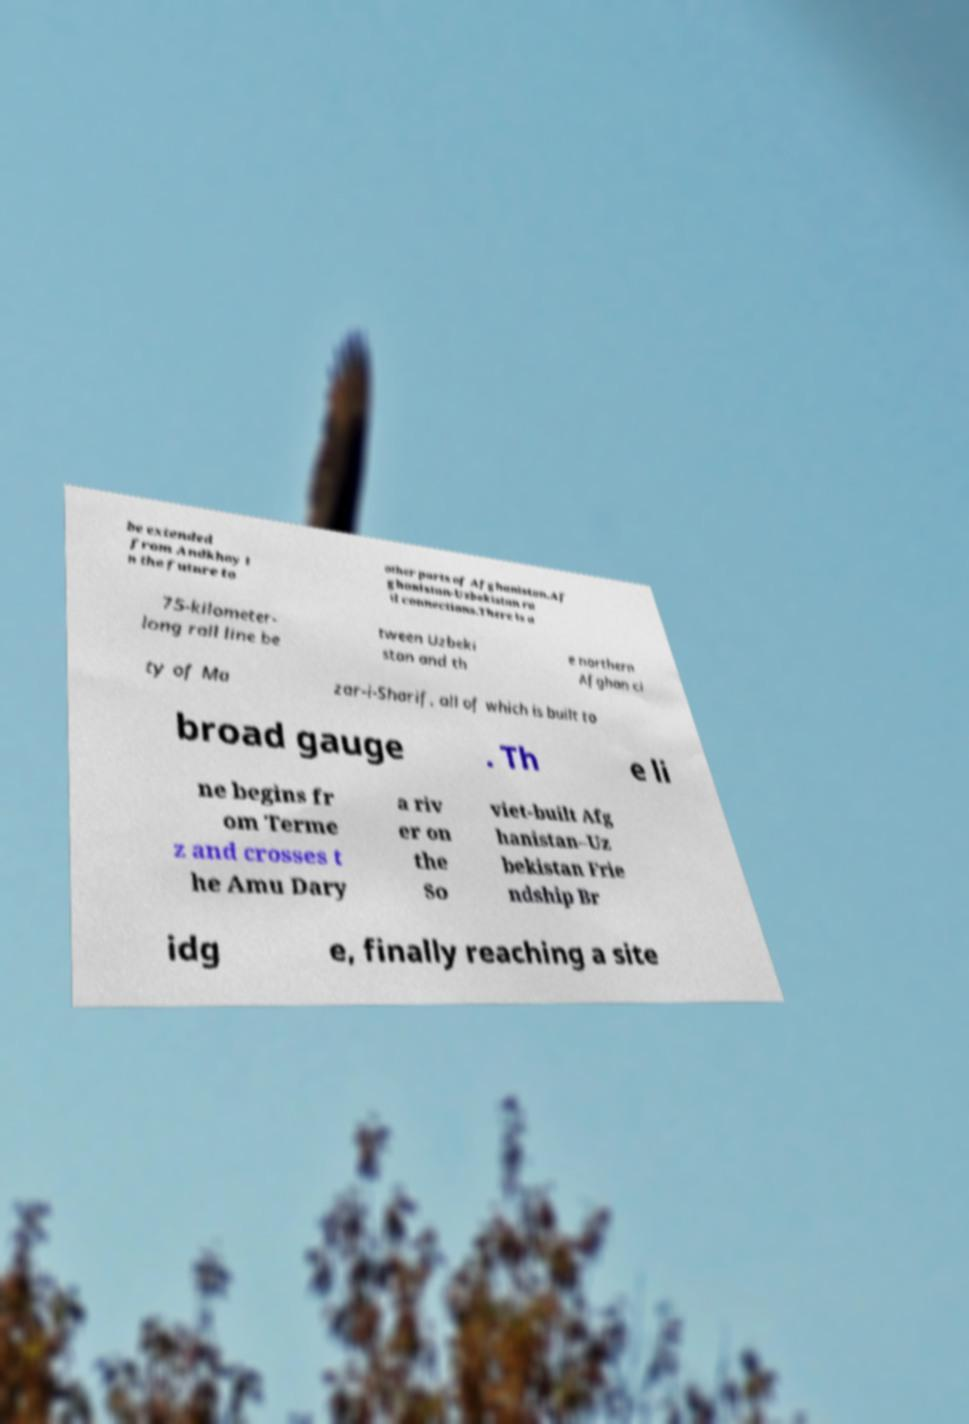What messages or text are displayed in this image? I need them in a readable, typed format. be extended from Andkhoy i n the future to other parts of Afghanistan.Af ghanistan-Uzbekistan ra il connections.There is a 75-kilometer- long rail line be tween Uzbeki stan and th e northern Afghan ci ty of Ma zar-i-Sharif, all of which is built to broad gauge . Th e li ne begins fr om Terme z and crosses t he Amu Dary a riv er on the So viet-built Afg hanistan–Uz bekistan Frie ndship Br idg e, finally reaching a site 